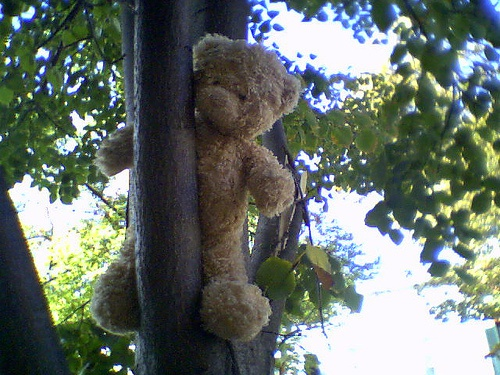Describe the objects in this image and their specific colors. I can see a teddy bear in black and gray tones in this image. 